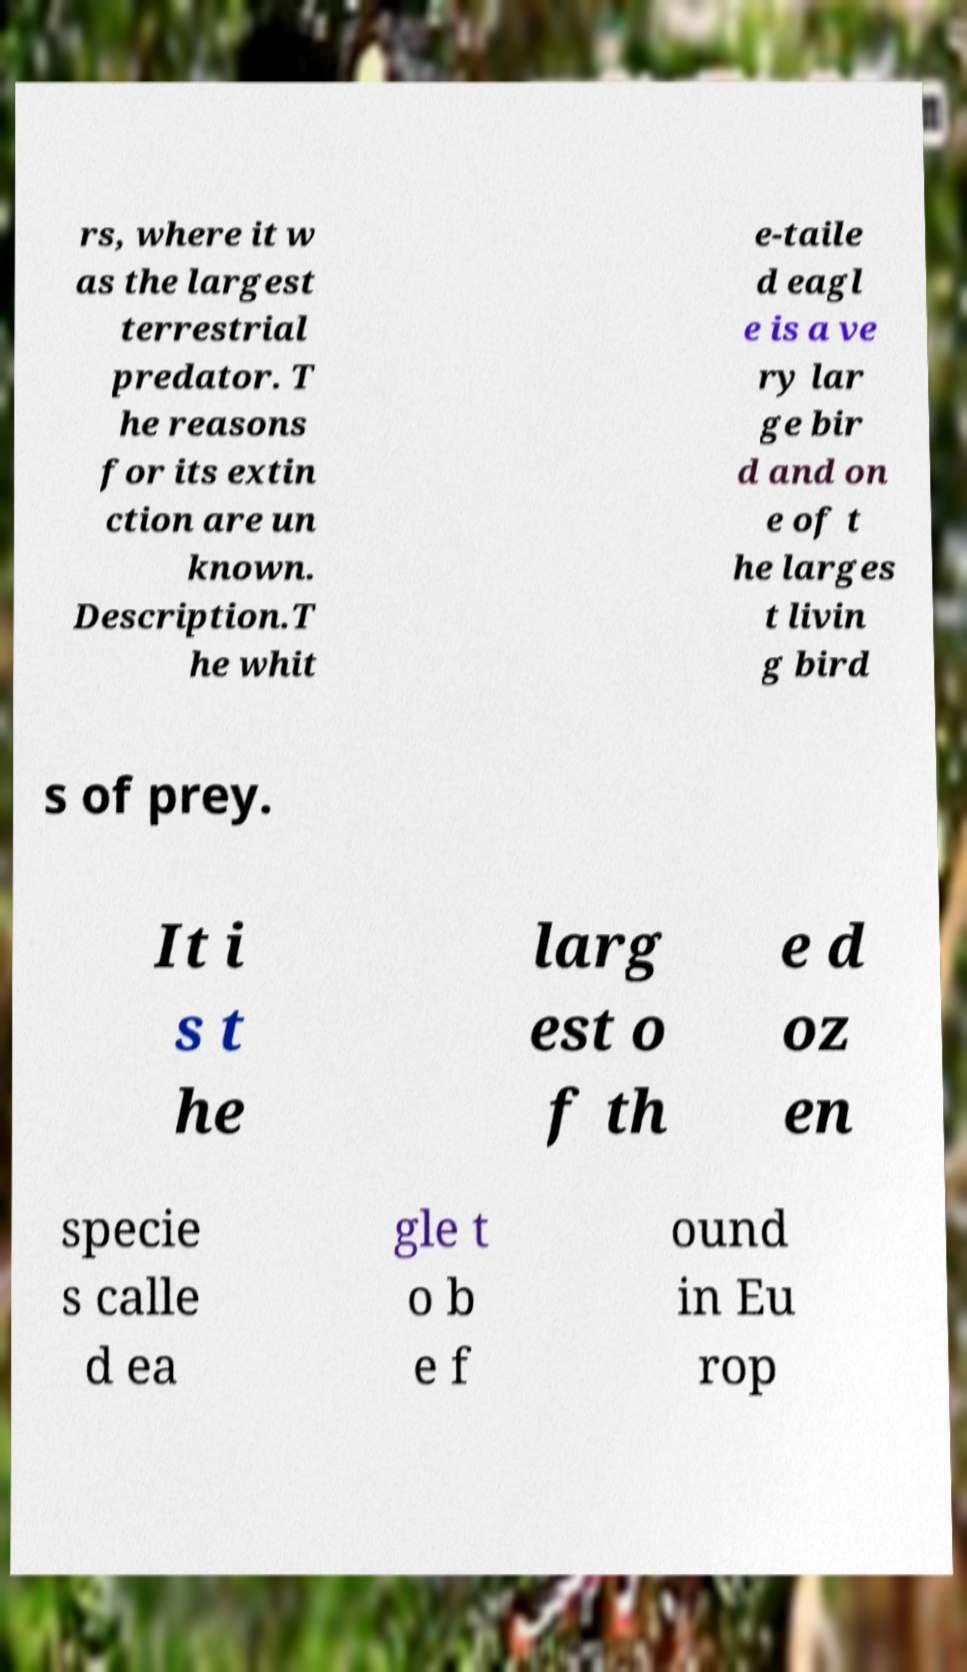There's text embedded in this image that I need extracted. Can you transcribe it verbatim? rs, where it w as the largest terrestrial predator. T he reasons for its extin ction are un known. Description.T he whit e-taile d eagl e is a ve ry lar ge bir d and on e of t he larges t livin g bird s of prey. It i s t he larg est o f th e d oz en specie s calle d ea gle t o b e f ound in Eu rop 